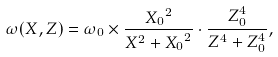<formula> <loc_0><loc_0><loc_500><loc_500>\omega ( X , Z ) = \omega _ { 0 } \times \frac { { X _ { 0 } } ^ { 2 } } { X ^ { 2 } + { X _ { 0 } } ^ { 2 } } \cdot \frac { Z _ { 0 } ^ { 4 } } { Z ^ { 4 } + Z _ { 0 } ^ { 4 } } ,</formula> 